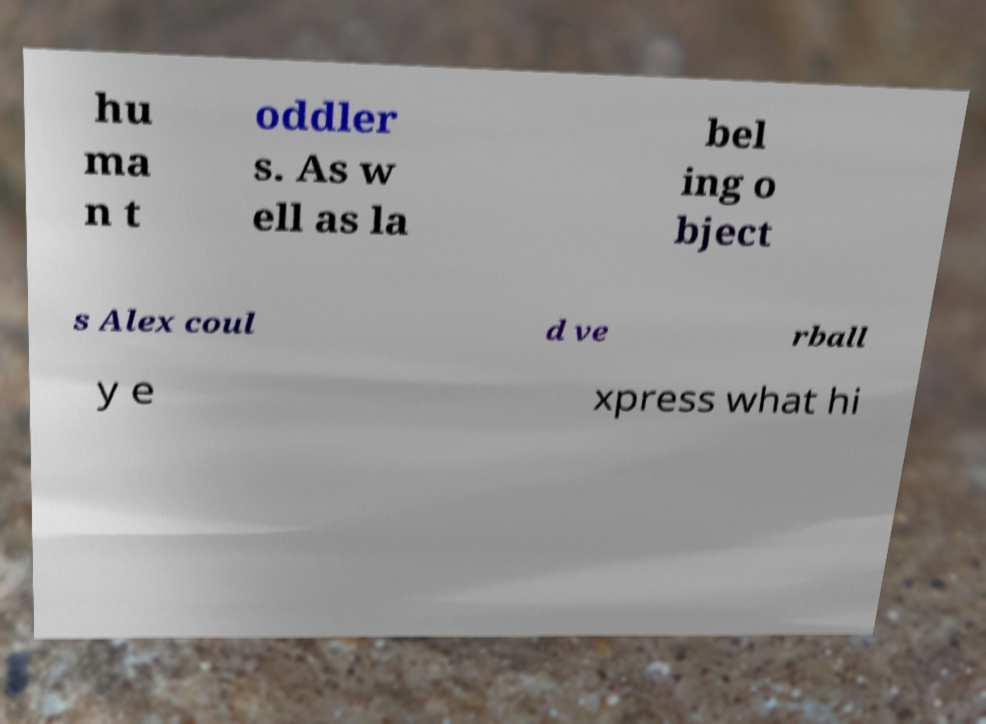Could you assist in decoding the text presented in this image and type it out clearly? hu ma n t oddler s. As w ell as la bel ing o bject s Alex coul d ve rball y e xpress what hi 